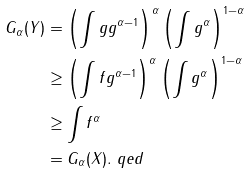Convert formula to latex. <formula><loc_0><loc_0><loc_500><loc_500>G _ { \alpha } ( Y ) & = \left ( \int g g ^ { \alpha - 1 } \right ) ^ { \alpha } \left ( \int g ^ { \alpha } \right ) ^ { 1 - \alpha } \\ & \geq \left ( \int f g ^ { \alpha - 1 } \right ) ^ { \alpha } \left ( \int g ^ { \alpha } \right ) ^ { 1 - \alpha } \\ & \geq \int f ^ { \alpha } \\ & = G _ { \alpha } ( X ) . \ q e d</formula> 